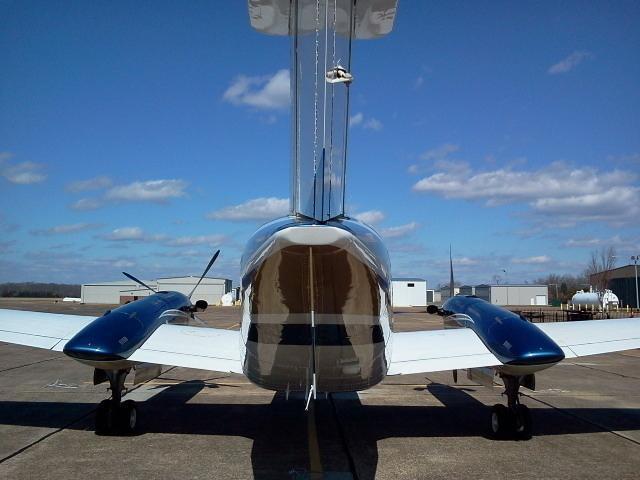How many boats are there?
Give a very brief answer. 0. 